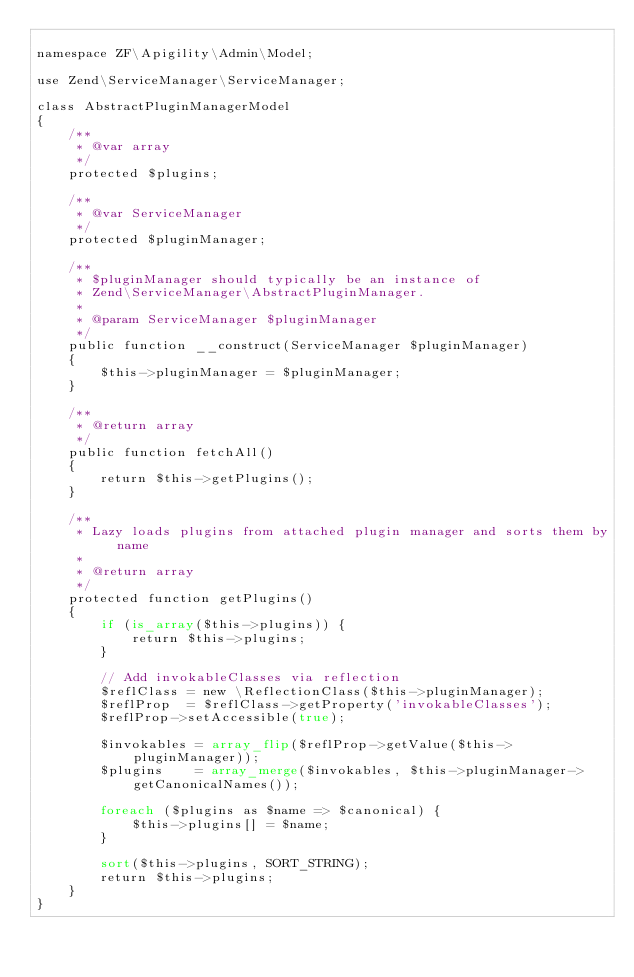<code> <loc_0><loc_0><loc_500><loc_500><_PHP_>
namespace ZF\Apigility\Admin\Model;

use Zend\ServiceManager\ServiceManager;

class AbstractPluginManagerModel
{
    /**
     * @var array
     */
    protected $plugins;

    /**
     * @var ServiceManager
     */
    protected $pluginManager;

    /**
     * $pluginManager should typically be an instance of
     * Zend\ServiceManager\AbstractPluginManager.
     *
     * @param ServiceManager $pluginManager
     */
    public function __construct(ServiceManager $pluginManager)
    {
        $this->pluginManager = $pluginManager;
    }

    /**
     * @return array
     */
    public function fetchAll()
    {
        return $this->getPlugins();
    }

    /**
     * Lazy loads plugins from attached plugin manager and sorts them by name
     *
     * @return array
     */
    protected function getPlugins()
    {
        if (is_array($this->plugins)) {
            return $this->plugins;
        }

        // Add invokableClasses via reflection
        $reflClass = new \ReflectionClass($this->pluginManager);
        $reflProp  = $reflClass->getProperty('invokableClasses');
        $reflProp->setAccessible(true);

        $invokables = array_flip($reflProp->getValue($this->pluginManager));
        $plugins    = array_merge($invokables, $this->pluginManager->getCanonicalNames());

        foreach ($plugins as $name => $canonical) {
            $this->plugins[] = $name;
        }

        sort($this->plugins, SORT_STRING);
        return $this->plugins;
    }
}
</code> 